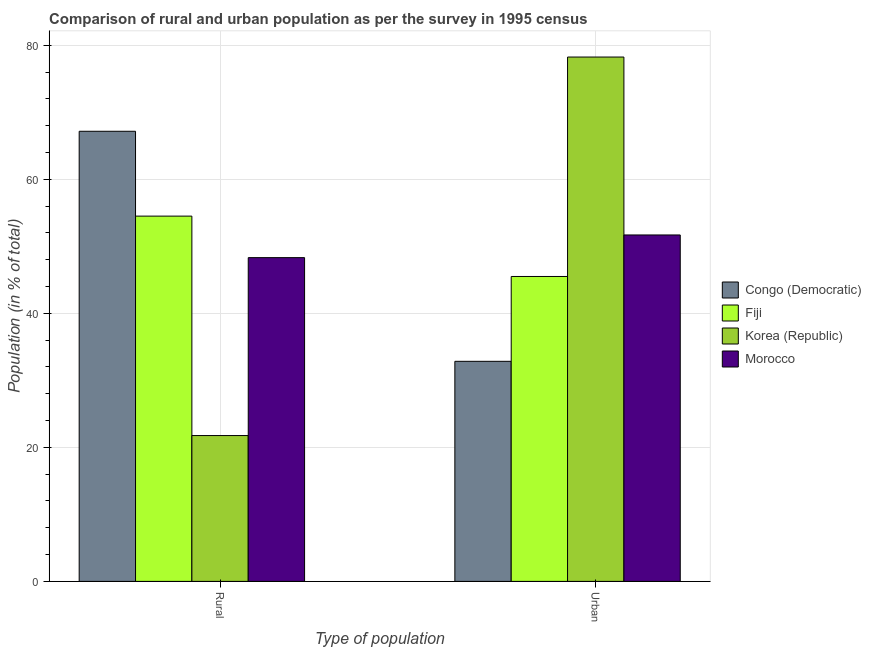How many groups of bars are there?
Your answer should be very brief. 2. Are the number of bars per tick equal to the number of legend labels?
Your answer should be very brief. Yes. Are the number of bars on each tick of the X-axis equal?
Provide a short and direct response. Yes. What is the label of the 2nd group of bars from the left?
Offer a terse response. Urban. What is the rural population in Korea (Republic)?
Provide a short and direct response. 21.76. Across all countries, what is the maximum rural population?
Offer a terse response. 67.16. Across all countries, what is the minimum rural population?
Give a very brief answer. 21.76. In which country was the urban population maximum?
Your response must be concise. Korea (Republic). In which country was the urban population minimum?
Provide a succinct answer. Congo (Democratic). What is the total rural population in the graph?
Make the answer very short. 191.73. What is the difference between the rural population in Congo (Democratic) and that in Korea (Republic)?
Your answer should be compact. 45.4. What is the difference between the rural population in Congo (Democratic) and the urban population in Korea (Republic)?
Make the answer very short. -11.08. What is the average urban population per country?
Offer a very short reply. 52.07. What is the difference between the urban population and rural population in Morocco?
Make the answer very short. 3.38. What is the ratio of the urban population in Morocco to that in Congo (Democratic)?
Offer a very short reply. 1.57. What does the 1st bar from the left in Urban represents?
Your answer should be very brief. Congo (Democratic). What does the 3rd bar from the right in Urban represents?
Provide a short and direct response. Fiji. How many bars are there?
Give a very brief answer. 8. Are all the bars in the graph horizontal?
Make the answer very short. No. Are the values on the major ticks of Y-axis written in scientific E-notation?
Your response must be concise. No. Does the graph contain any zero values?
Your answer should be compact. No. How many legend labels are there?
Ensure brevity in your answer.  4. How are the legend labels stacked?
Give a very brief answer. Vertical. What is the title of the graph?
Make the answer very short. Comparison of rural and urban population as per the survey in 1995 census. Does "Haiti" appear as one of the legend labels in the graph?
Offer a terse response. No. What is the label or title of the X-axis?
Provide a short and direct response. Type of population. What is the label or title of the Y-axis?
Make the answer very short. Population (in % of total). What is the Population (in % of total) of Congo (Democratic) in Rural?
Offer a terse response. 67.16. What is the Population (in % of total) in Fiji in Rural?
Give a very brief answer. 54.5. What is the Population (in % of total) of Korea (Republic) in Rural?
Keep it short and to the point. 21.76. What is the Population (in % of total) of Morocco in Rural?
Your answer should be compact. 48.31. What is the Population (in % of total) in Congo (Democratic) in Urban?
Keep it short and to the point. 32.84. What is the Population (in % of total) of Fiji in Urban?
Make the answer very short. 45.5. What is the Population (in % of total) in Korea (Republic) in Urban?
Make the answer very short. 78.24. What is the Population (in % of total) of Morocco in Urban?
Your answer should be very brief. 51.69. Across all Type of population, what is the maximum Population (in % of total) in Congo (Democratic)?
Ensure brevity in your answer.  67.16. Across all Type of population, what is the maximum Population (in % of total) of Fiji?
Provide a short and direct response. 54.5. Across all Type of population, what is the maximum Population (in % of total) in Korea (Republic)?
Your answer should be compact. 78.24. Across all Type of population, what is the maximum Population (in % of total) in Morocco?
Your answer should be very brief. 51.69. Across all Type of population, what is the minimum Population (in % of total) of Congo (Democratic)?
Offer a very short reply. 32.84. Across all Type of population, what is the minimum Population (in % of total) in Fiji?
Your response must be concise. 45.5. Across all Type of population, what is the minimum Population (in % of total) of Korea (Republic)?
Provide a succinct answer. 21.76. Across all Type of population, what is the minimum Population (in % of total) in Morocco?
Give a very brief answer. 48.31. What is the total Population (in % of total) in Korea (Republic) in the graph?
Make the answer very short. 100. What is the difference between the Population (in % of total) of Congo (Democratic) in Rural and that in Urban?
Provide a succinct answer. 34.32. What is the difference between the Population (in % of total) of Fiji in Rural and that in Urban?
Provide a short and direct response. 9.01. What is the difference between the Population (in % of total) in Korea (Republic) in Rural and that in Urban?
Offer a very short reply. -56.48. What is the difference between the Population (in % of total) of Morocco in Rural and that in Urban?
Your answer should be very brief. -3.38. What is the difference between the Population (in % of total) in Congo (Democratic) in Rural and the Population (in % of total) in Fiji in Urban?
Ensure brevity in your answer.  21.67. What is the difference between the Population (in % of total) of Congo (Democratic) in Rural and the Population (in % of total) of Korea (Republic) in Urban?
Provide a short and direct response. -11.08. What is the difference between the Population (in % of total) in Congo (Democratic) in Rural and the Population (in % of total) in Morocco in Urban?
Your response must be concise. 15.47. What is the difference between the Population (in % of total) of Fiji in Rural and the Population (in % of total) of Korea (Republic) in Urban?
Ensure brevity in your answer.  -23.73. What is the difference between the Population (in % of total) of Fiji in Rural and the Population (in % of total) of Morocco in Urban?
Make the answer very short. 2.81. What is the difference between the Population (in % of total) of Korea (Republic) in Rural and the Population (in % of total) of Morocco in Urban?
Make the answer very short. -29.93. What is the average Population (in % of total) of Congo (Democratic) per Type of population?
Your answer should be very brief. 50. What is the average Population (in % of total) in Morocco per Type of population?
Ensure brevity in your answer.  50. What is the difference between the Population (in % of total) in Congo (Democratic) and Population (in % of total) in Fiji in Rural?
Your answer should be very brief. 12.66. What is the difference between the Population (in % of total) in Congo (Democratic) and Population (in % of total) in Korea (Republic) in Rural?
Make the answer very short. 45.4. What is the difference between the Population (in % of total) of Congo (Democratic) and Population (in % of total) of Morocco in Rural?
Ensure brevity in your answer.  18.85. What is the difference between the Population (in % of total) of Fiji and Population (in % of total) of Korea (Republic) in Rural?
Give a very brief answer. 32.74. What is the difference between the Population (in % of total) in Fiji and Population (in % of total) in Morocco in Rural?
Your answer should be very brief. 6.2. What is the difference between the Population (in % of total) of Korea (Republic) and Population (in % of total) of Morocco in Rural?
Ensure brevity in your answer.  -26.55. What is the difference between the Population (in % of total) in Congo (Democratic) and Population (in % of total) in Fiji in Urban?
Your answer should be very brief. -12.66. What is the difference between the Population (in % of total) in Congo (Democratic) and Population (in % of total) in Korea (Republic) in Urban?
Ensure brevity in your answer.  -45.4. What is the difference between the Population (in % of total) of Congo (Democratic) and Population (in % of total) of Morocco in Urban?
Your answer should be very brief. -18.85. What is the difference between the Population (in % of total) of Fiji and Population (in % of total) of Korea (Republic) in Urban?
Provide a succinct answer. -32.74. What is the difference between the Population (in % of total) in Fiji and Population (in % of total) in Morocco in Urban?
Your answer should be very brief. -6.2. What is the difference between the Population (in % of total) in Korea (Republic) and Population (in % of total) in Morocco in Urban?
Your answer should be compact. 26.55. What is the ratio of the Population (in % of total) of Congo (Democratic) in Rural to that in Urban?
Your answer should be compact. 2.05. What is the ratio of the Population (in % of total) of Fiji in Rural to that in Urban?
Give a very brief answer. 1.2. What is the ratio of the Population (in % of total) in Korea (Republic) in Rural to that in Urban?
Keep it short and to the point. 0.28. What is the ratio of the Population (in % of total) of Morocco in Rural to that in Urban?
Make the answer very short. 0.93. What is the difference between the highest and the second highest Population (in % of total) of Congo (Democratic)?
Ensure brevity in your answer.  34.32. What is the difference between the highest and the second highest Population (in % of total) in Fiji?
Keep it short and to the point. 9.01. What is the difference between the highest and the second highest Population (in % of total) of Korea (Republic)?
Your answer should be very brief. 56.48. What is the difference between the highest and the second highest Population (in % of total) in Morocco?
Give a very brief answer. 3.38. What is the difference between the highest and the lowest Population (in % of total) in Congo (Democratic)?
Your response must be concise. 34.32. What is the difference between the highest and the lowest Population (in % of total) of Fiji?
Make the answer very short. 9.01. What is the difference between the highest and the lowest Population (in % of total) of Korea (Republic)?
Your answer should be compact. 56.48. What is the difference between the highest and the lowest Population (in % of total) of Morocco?
Give a very brief answer. 3.38. 